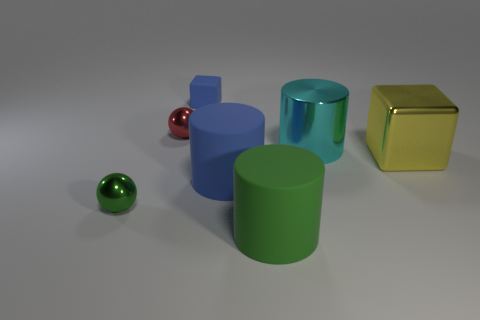Add 3 big rubber cylinders. How many objects exist? 10 Subtract all cylinders. How many objects are left? 4 Add 2 large metallic cylinders. How many large metallic cylinders are left? 3 Add 4 purple matte blocks. How many purple matte blocks exist? 4 Subtract 0 brown cylinders. How many objects are left? 7 Subtract all blue metallic spheres. Subtract all small blue rubber things. How many objects are left? 6 